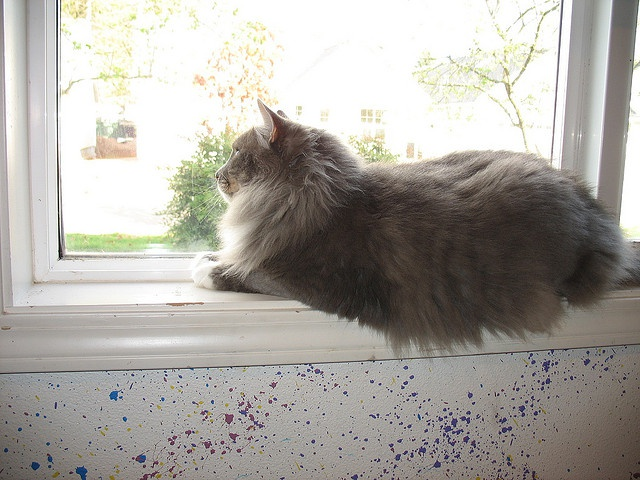Describe the objects in this image and their specific colors. I can see a cat in gray, black, and darkgray tones in this image. 